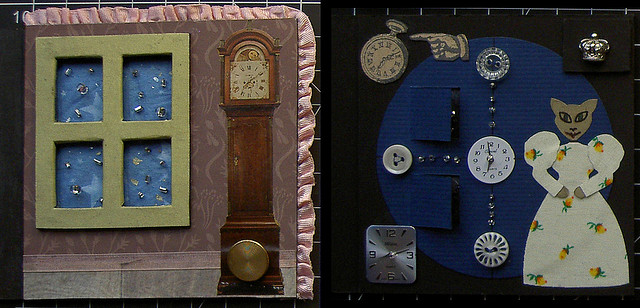<image>What letter is next to the cat? There is no letter in the image next to the cat. What letter is next to the cat? There is no letter next to the cat in the image. 